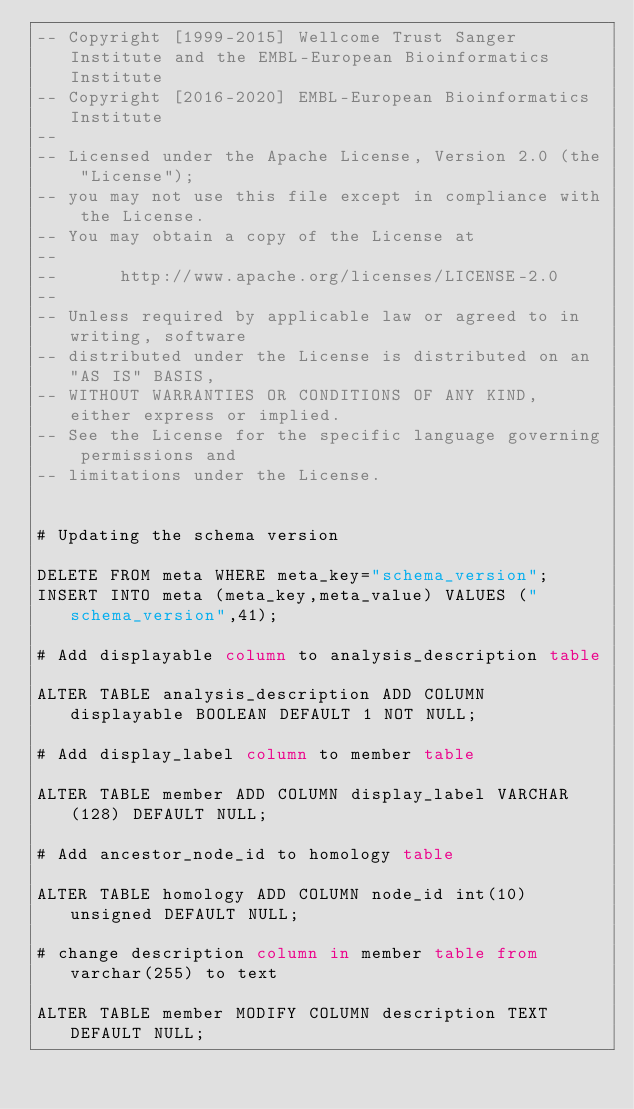<code> <loc_0><loc_0><loc_500><loc_500><_SQL_>-- Copyright [1999-2015] Wellcome Trust Sanger Institute and the EMBL-European Bioinformatics Institute
-- Copyright [2016-2020] EMBL-European Bioinformatics Institute
-- 
-- Licensed under the Apache License, Version 2.0 (the "License");
-- you may not use this file except in compliance with the License.
-- You may obtain a copy of the License at
-- 
--      http://www.apache.org/licenses/LICENSE-2.0
-- 
-- Unless required by applicable law or agreed to in writing, software
-- distributed under the License is distributed on an "AS IS" BASIS,
-- WITHOUT WARRANTIES OR CONDITIONS OF ANY KIND, either express or implied.
-- See the License for the specific language governing permissions and
-- limitations under the License.


# Updating the schema version

DELETE FROM meta WHERE meta_key="schema_version";
INSERT INTO meta (meta_key,meta_value) VALUES ("schema_version",41);

# Add displayable column to analysis_description table

ALTER TABLE analysis_description ADD COLUMN displayable BOOLEAN DEFAULT 1 NOT NULL;

# Add display_label column to member table

ALTER TABLE member ADD COLUMN display_label VARCHAR(128) DEFAULT NULL;

# Add ancestor_node_id to homology table

ALTER TABLE homology ADD COLUMN node_id int(10) unsigned DEFAULT NULL;

# change description column in member table from varchar(255) to text

ALTER TABLE member MODIFY COLUMN description TEXT DEFAULT NULL;
</code> 